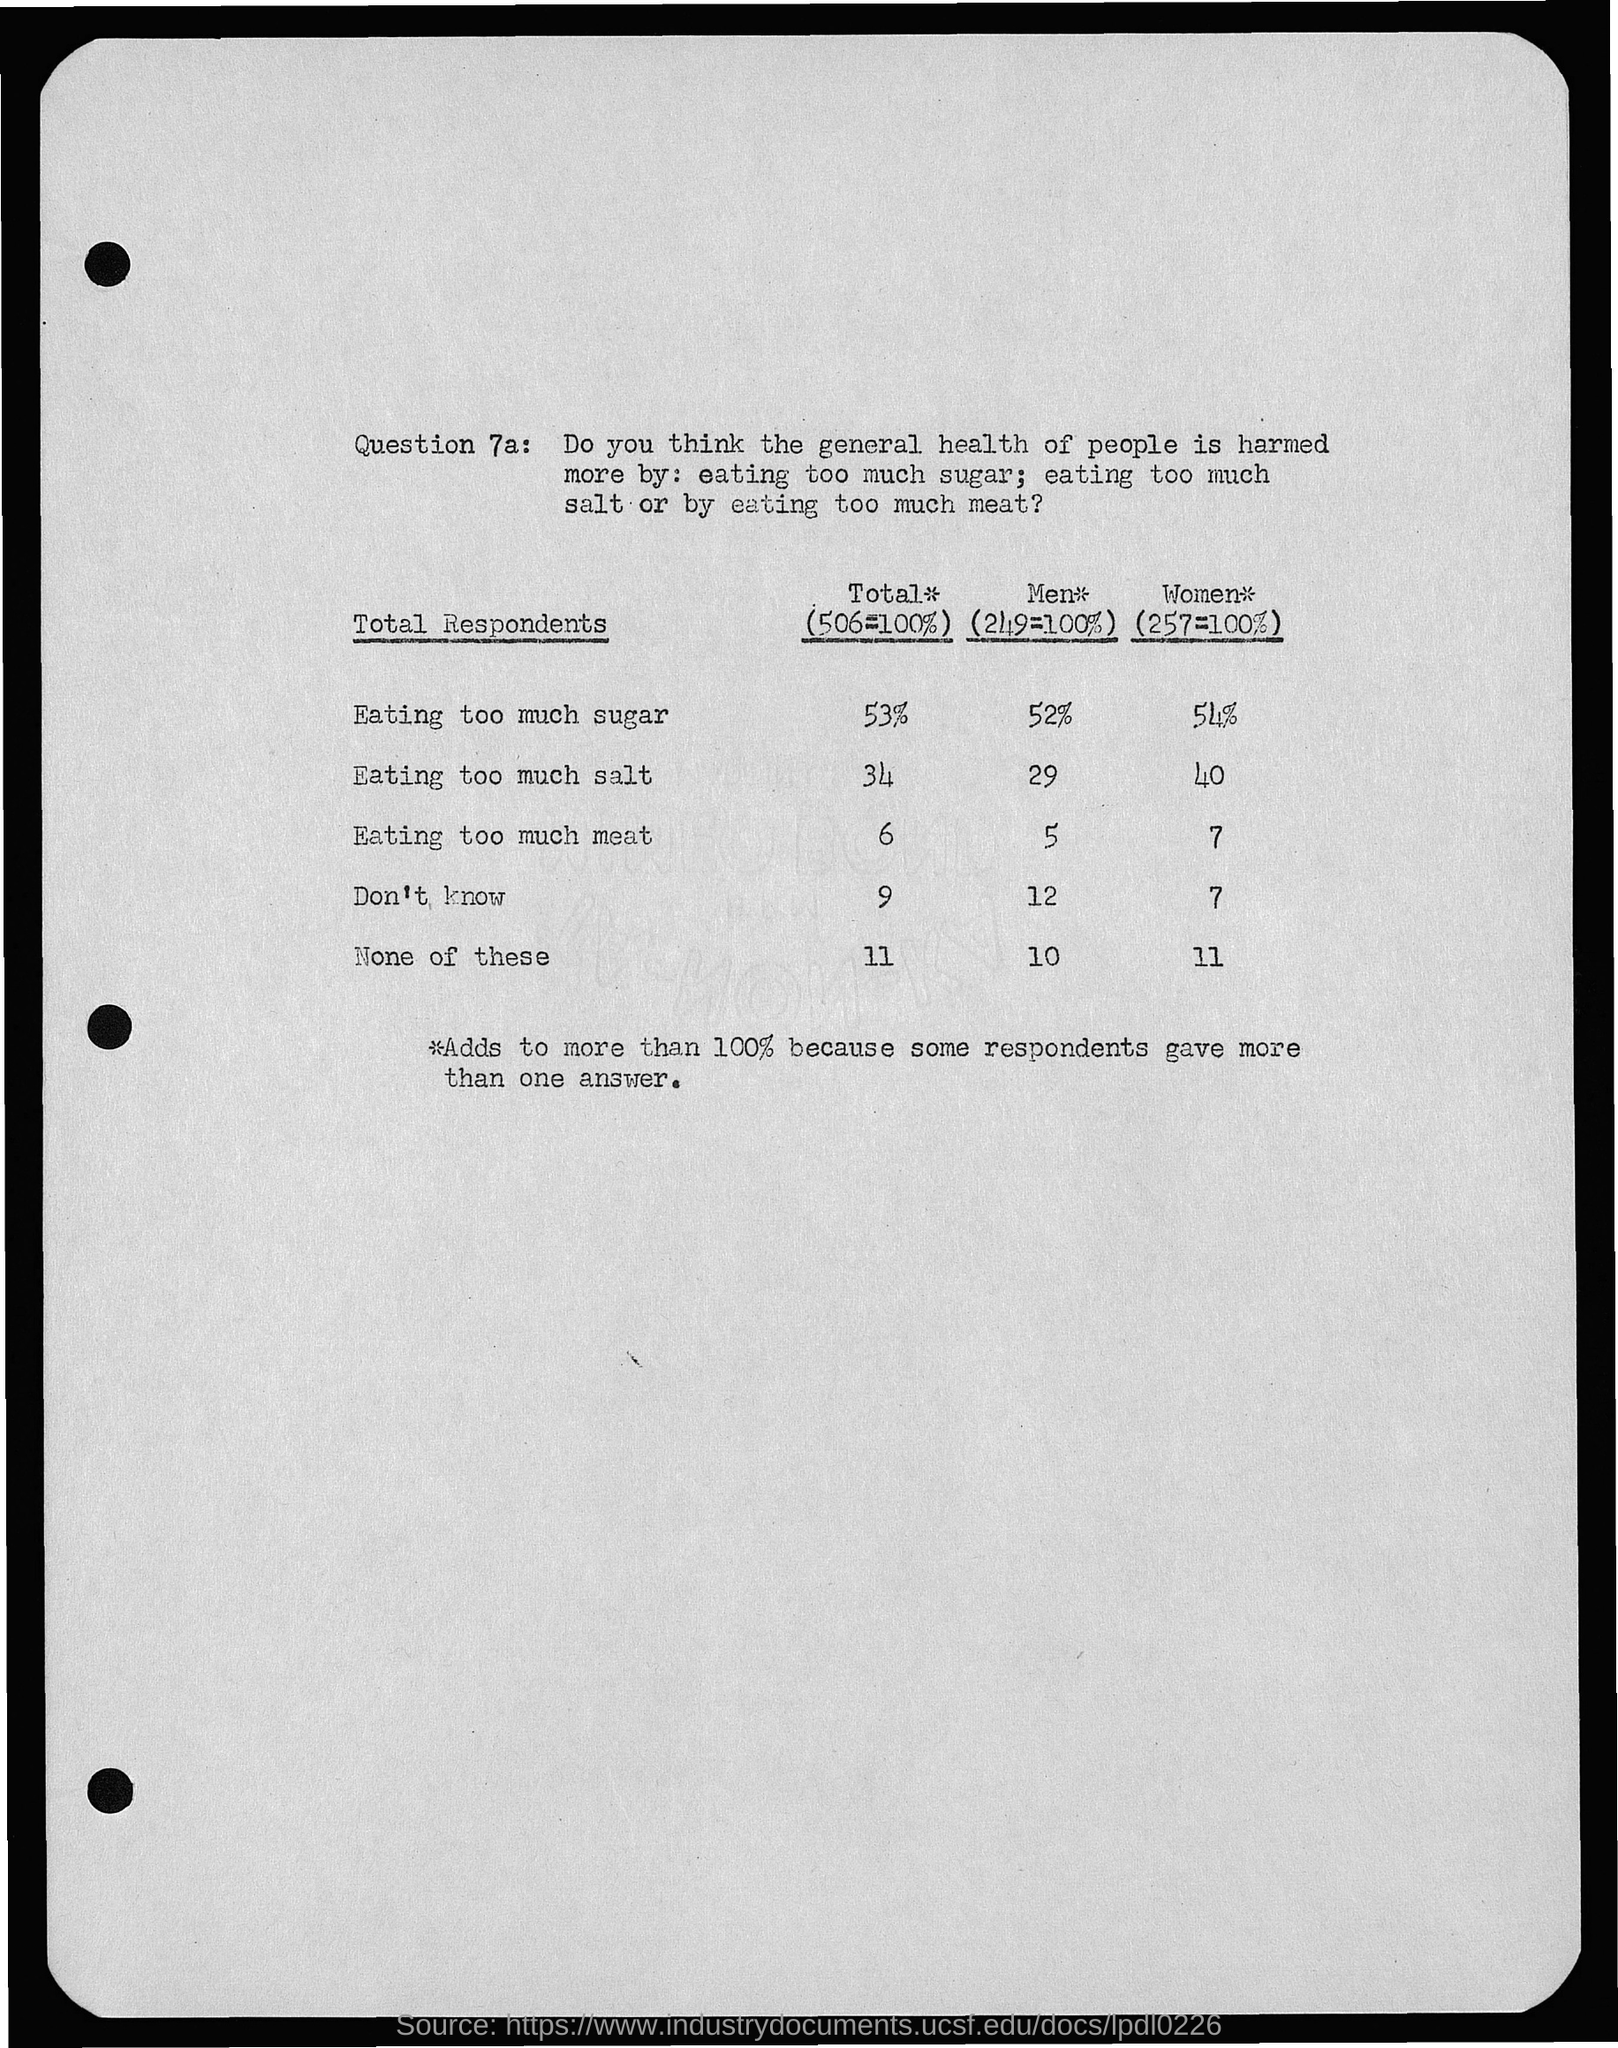How do the views on eating too much salt differ between men and women? The survey in the image shows that there is a notable difference between men and women concerning the consumption of too much salt. While 29% of men consider it the most harmful dietary issue, a larger portion, 40% of women, view eating too much salt as being more detrimental to health. 